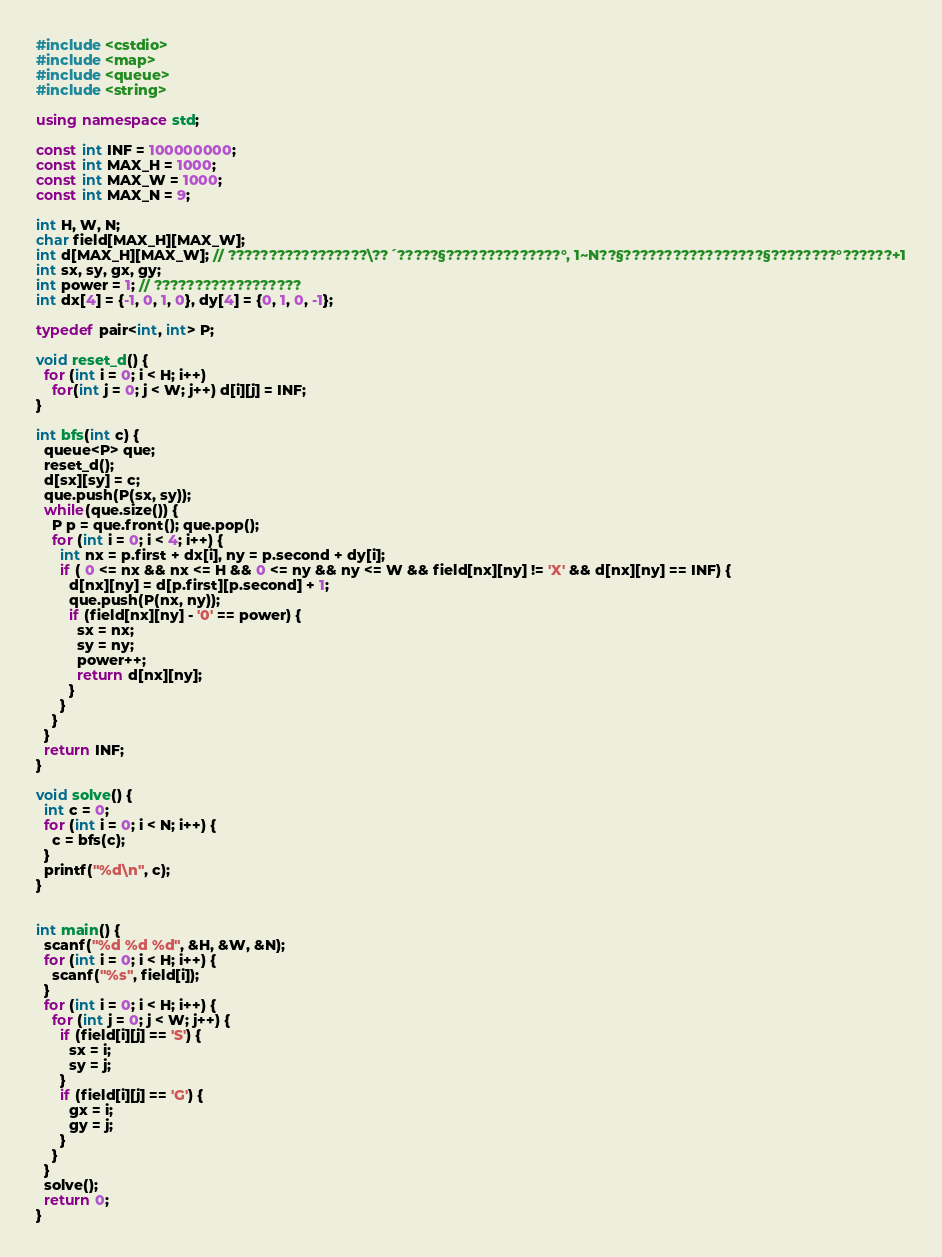<code> <loc_0><loc_0><loc_500><loc_500><_C++_>#include <cstdio>
#include <map>
#include <queue>
#include <string>

using namespace std;

const int INF = 100000000;
const int MAX_H = 1000;
const int MAX_W = 1000;
const int MAX_N = 9;

int H, W, N;
char field[MAX_H][MAX_W];
int d[MAX_H][MAX_W]; // ?????????????????\??´?????§??????????????°, 1~N??§?????????????????§????????°??????+1
int sx, sy, gx, gy;
int power = 1; // ??????????????????
int dx[4] = {-1, 0, 1, 0}, dy[4] = {0, 1, 0, -1};

typedef pair<int, int> P;

void reset_d() {
  for (int i = 0; i < H; i++)
    for(int j = 0; j < W; j++) d[i][j] = INF;
}

int bfs(int c) {
  queue<P> que;
  reset_d();
  d[sx][sy] = c;
  que.push(P(sx, sy));
  while(que.size()) {
    P p = que.front(); que.pop();
    for (int i = 0; i < 4; i++) {
      int nx = p.first + dx[i], ny = p.second + dy[i];
      if ( 0 <= nx && nx <= H && 0 <= ny && ny <= W && field[nx][ny] != 'X' && d[nx][ny] == INF) {
        d[nx][ny] = d[p.first][p.second] + 1;
        que.push(P(nx, ny));
        if (field[nx][ny] - '0' == power) {
          sx = nx;
          sy = ny;
          power++;
          return d[nx][ny];
        }
      }
    }
  }
  return INF;
}

void solve() {
  int c = 0;
  for (int i = 0; i < N; i++) {
    c = bfs(c);
  }
  printf("%d\n", c);
}


int main() {
  scanf("%d %d %d", &H, &W, &N);
  for (int i = 0; i < H; i++) {
    scanf("%s", field[i]);
  }
  for (int i = 0; i < H; i++) {
    for (int j = 0; j < W; j++) {
      if (field[i][j] == 'S') {
        sx = i;
        sy = j;
      }
      if (field[i][j] == 'G') {
        gx = i;
        gy = j;
      }
    }
  }
  solve();
  return 0;
}</code> 